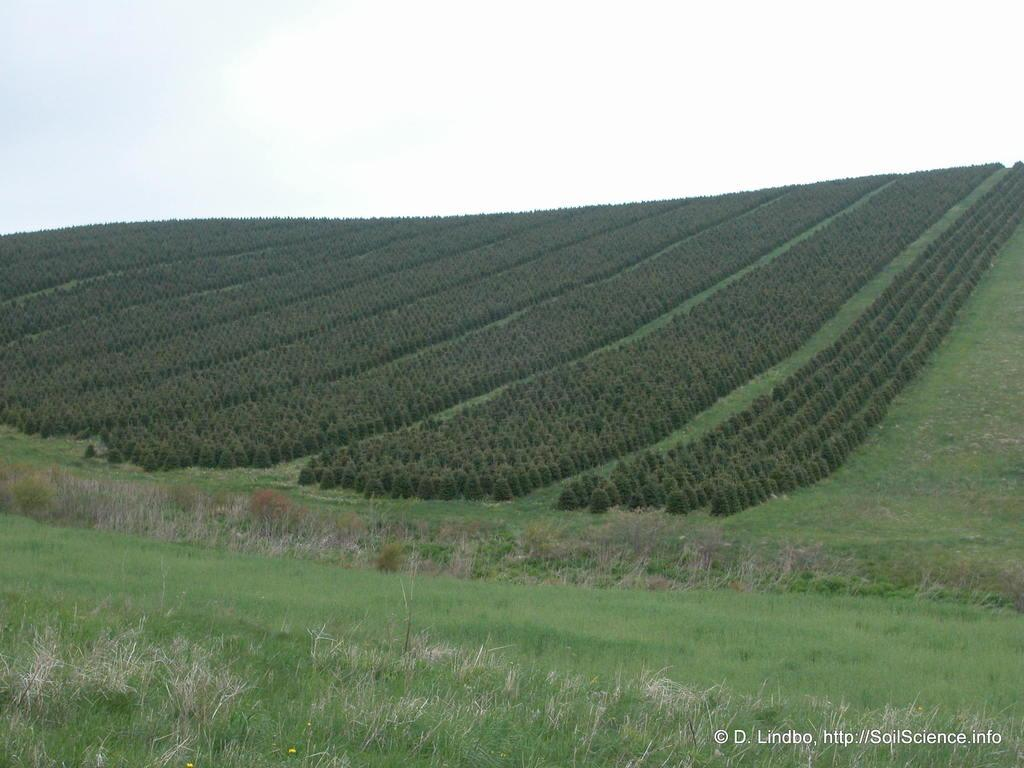What type of natural environment is visible in the image? There is grass and plants visible in the image, suggesting a natural environment. What is the color of the sky in the image? The sky is white in the image. Can you describe any additional features in the image? There is a watermark at the right bottom of the image. Where is the boat located in the image? There is no boat present in the image. What type of nest can be seen in the image? There is no nest present in the image. 